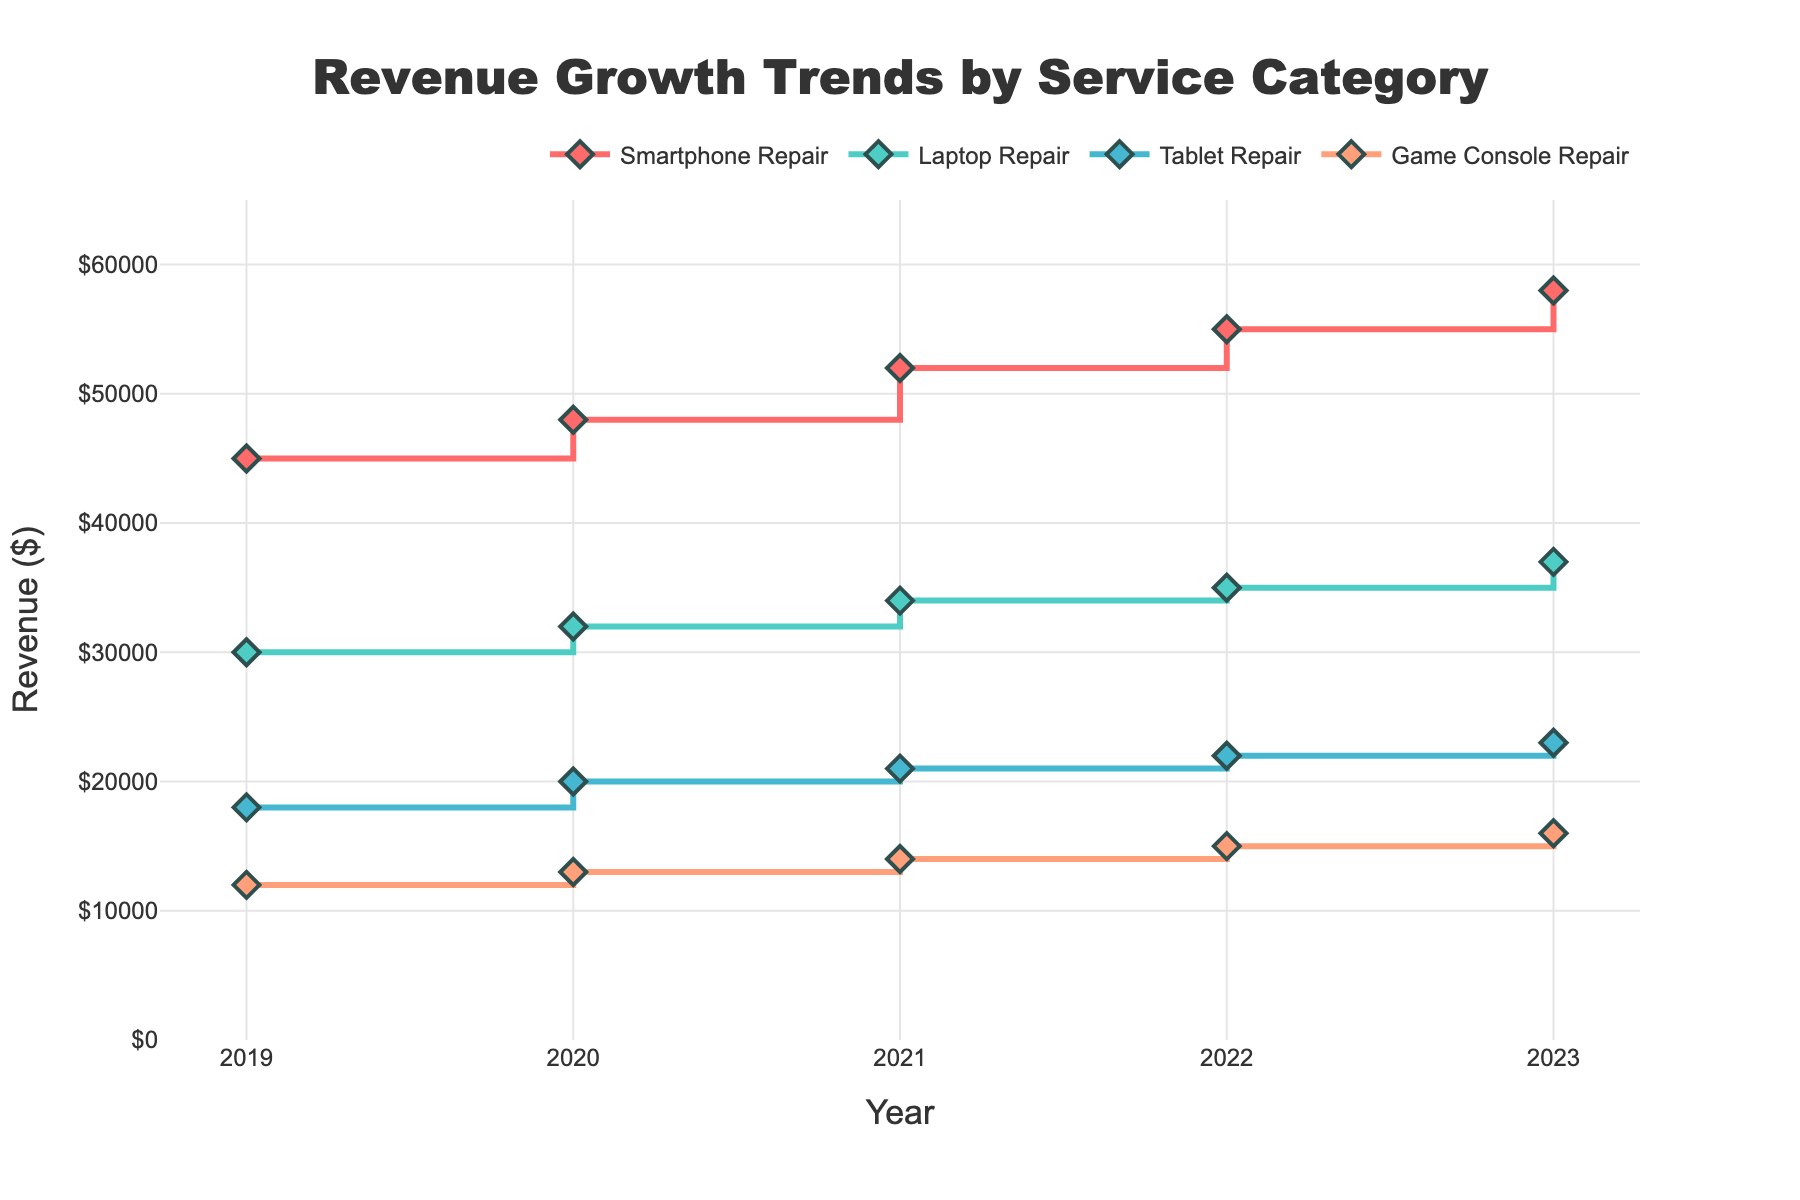What is the title of the plot? The title of the plot is written at the top and it reads "Revenue Growth Trends by Service Category."
Answer: Revenue Growth Trends by Service Category How many data points are there for each service category? Each service category has data points for every year from 2019 to 2023, which totals to 5 data points per category.
Answer: 5 Which service category had the highest revenue in 2023? By looking at the plot, the highest point in 2023 is for Smartphone Repair, indicating it had the highest revenue among all the service categories for that year.
Answer: Smartphone Repair Between which two years did "Laptop Repair" see its biggest increase in revenue? Laptop Repair saw its biggest increase between 2022 and 2023 as indicated by the steepest segment of the stair plot for that category.
Answer: 2022 and 2023 What was the revenue for "Tablet Repair" in 2021? The plot indicates the revenue for Tablet Repair in 2021 by the height of the step for that category in 2021, which is $21,000.
Answer: $21,000 What is the combined revenue of all categories in 2020? Add the revenues of all categories in 2020: Smartphone Repair ($48,000) + Laptop Repair ($32,000) + Tablet Repair ($20,000) + Game Console Repair ($13,000). This equals $113,000.
Answer: $113,000 Which service category showed the least amount of revenue growth from 2019 to 2023? By visually comparing the heights of the steps from 2019 to 2023, Game Console Repair shows the least growth. It grew from $12,000 to $16,000, an increase of $4,000.
Answer: Game Console Repair What is the average revenue of "Smartphone Repair" over the five years? Sum the revenues for Smartphone Repair from 2019 to 2023: ($45,000 + $48,000 + $52,000 + $55,000 + $58,000) = $258,000. The average revenue is $258,000 divided by 5, which is $51,600.
Answer: $51,600 What trend can be observed in the revenue for "Game Console Repair" over the five years? The trend for Game Console Repair shows a steady but slow increase in revenue each year.
Answer: Steady slow increase Which service category has the smallest revenue difference between 2022 and 2023? By comparing the differences in height of the steps between 2022 and 2023 for each category, Laptop Repair has the smallest difference. It increased by $2,000 (from $35,000 to $37,000).
Answer: Laptop Repair 